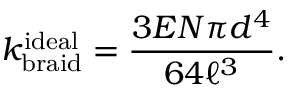Convert formula to latex. <formula><loc_0><loc_0><loc_500><loc_500>k _ { b r a i d } ^ { i d e a l } = \frac { 3 E N \pi d ^ { 4 } } { 6 4 \ell ^ { 3 } } .</formula> 